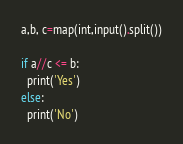<code> <loc_0><loc_0><loc_500><loc_500><_Python_>a,b, c=map(int,input().split())

if a//c <= b:
  print('Yes')
else:
  print('No')</code> 